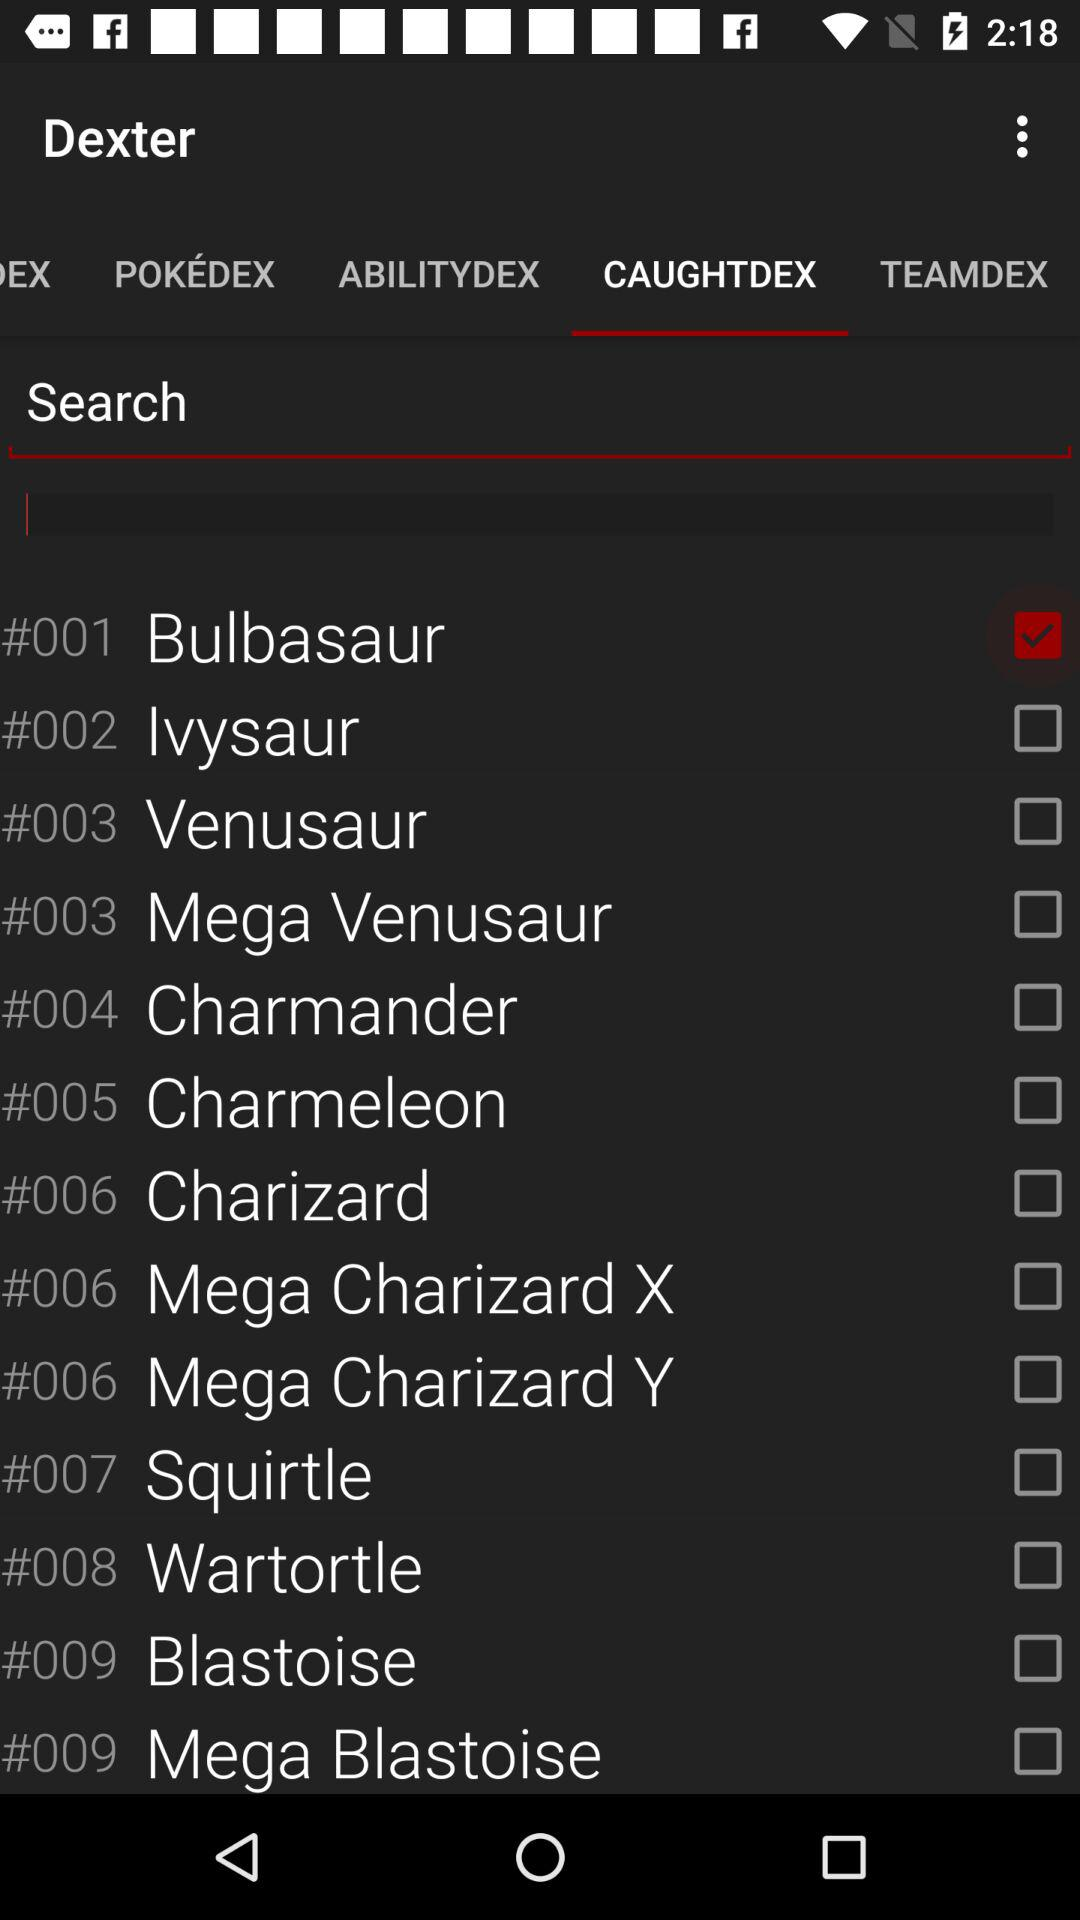What is the status of the Bulbasaur? The status of the Bulbasaur is on. 